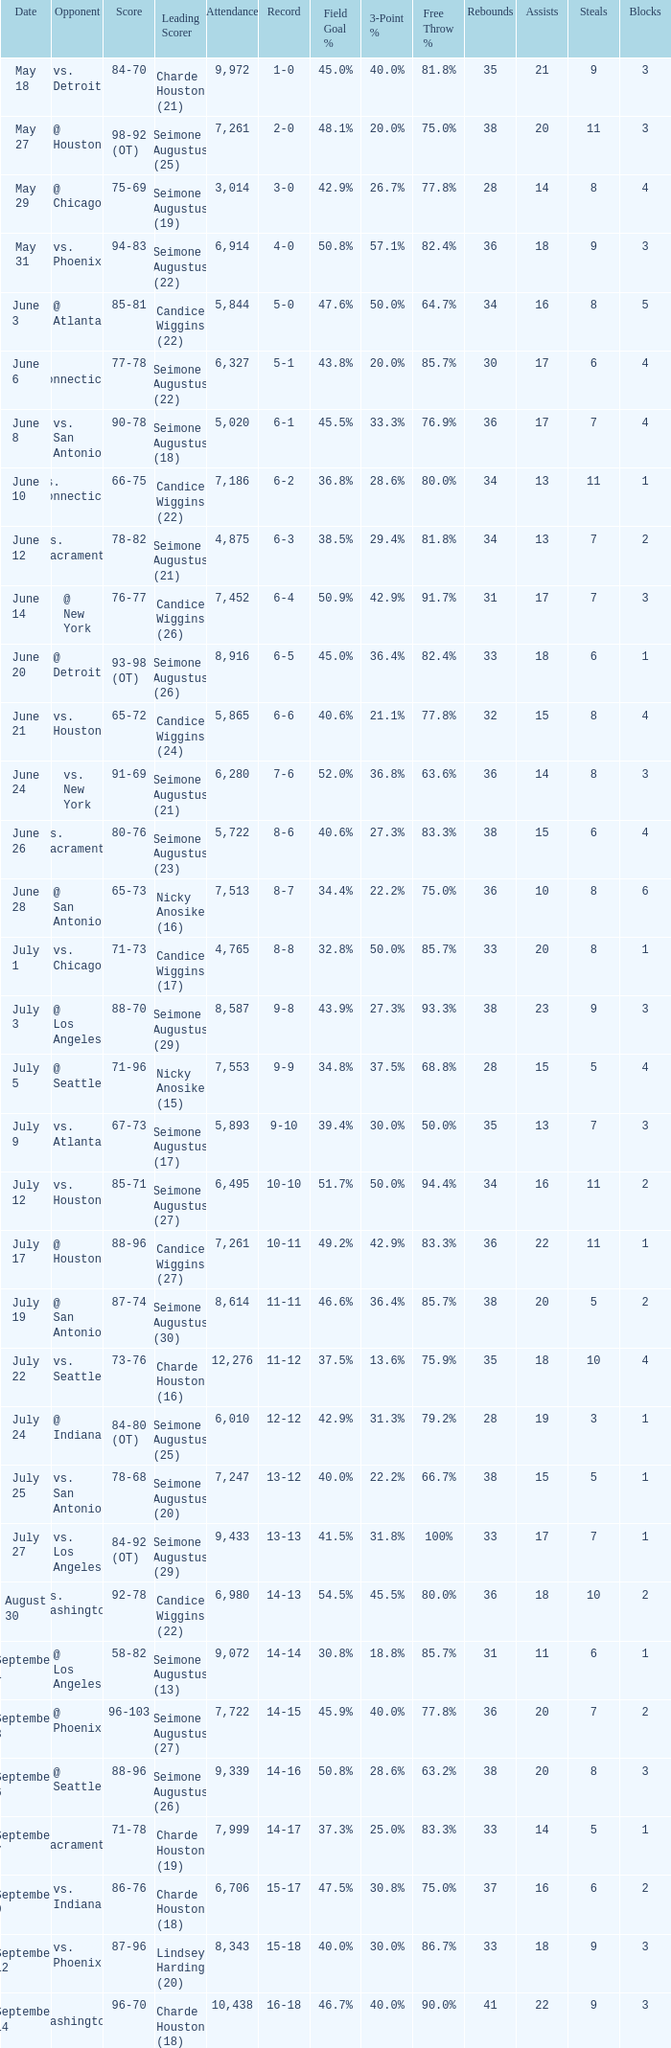Which Leading Scorer has an Opponent of @ seattle, and a Record of 14-16? Seimone Augustus (26). 